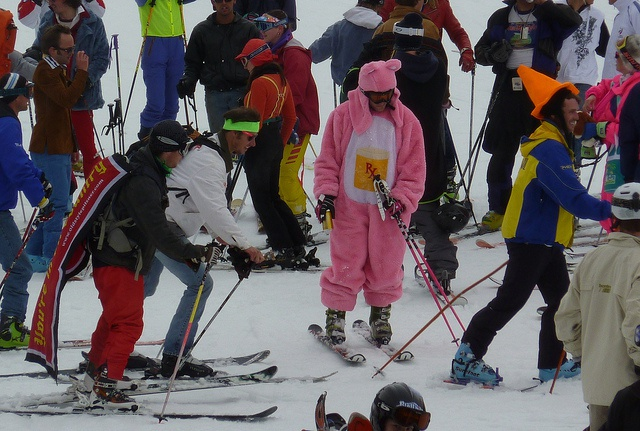Describe the objects in this image and their specific colors. I can see people in lightgray, black, darkgray, gray, and maroon tones, people in lightgray, brown, black, and darkgray tones, people in lightgray, black, navy, olive, and gray tones, people in lightgray, black, maroon, and gray tones, and people in lightgray, gray, and black tones in this image. 